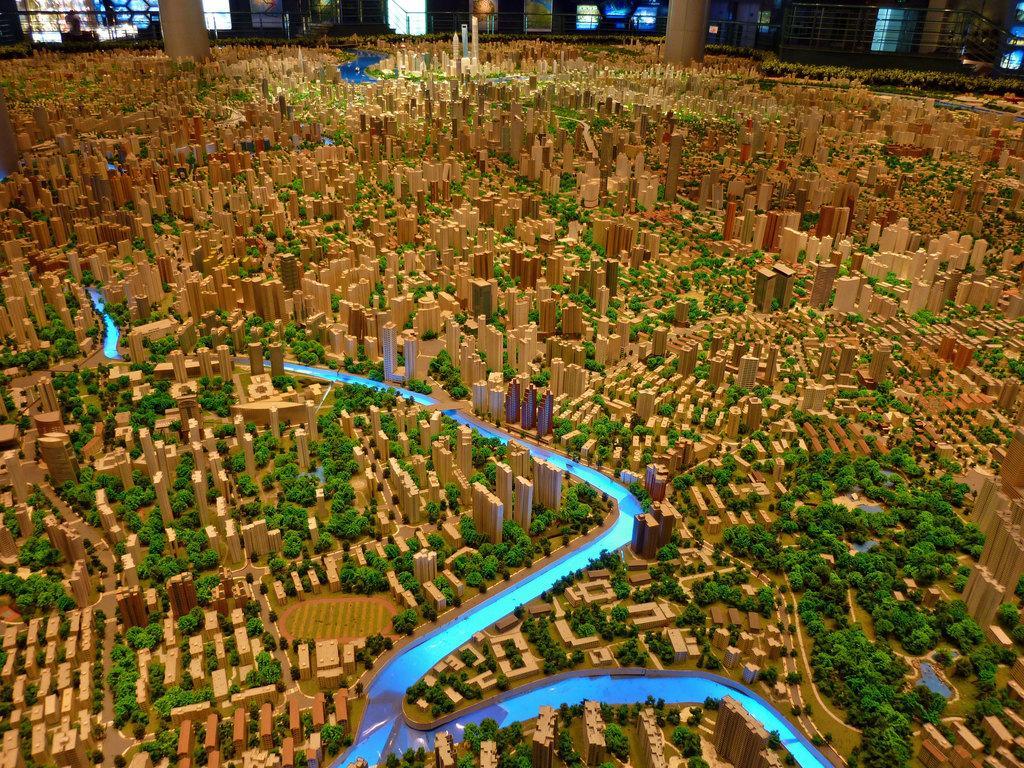How would you summarize this image in a sentence or two? This is the picture of a miniature. In this image there are buildings, trees and there is water. At the back there are pillars and there is a person standing. There is a railing. 